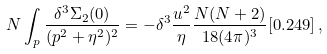<formula> <loc_0><loc_0><loc_500><loc_500>N \int _ { p } \frac { \delta ^ { 3 } \Sigma _ { 2 } ( 0 ) } { ( p ^ { 2 } + \eta ^ { 2 } ) ^ { 2 } } = - \delta ^ { 3 } \frac { u ^ { 2 } } { \eta } \frac { N ( N + 2 ) } { 1 8 ( 4 \pi ) ^ { 3 } } [ 0 . 2 4 9 ] \, ,</formula> 